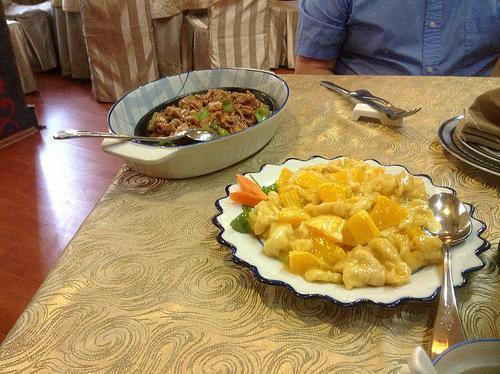How many people are in the photo?
Give a very brief answer. 1. 